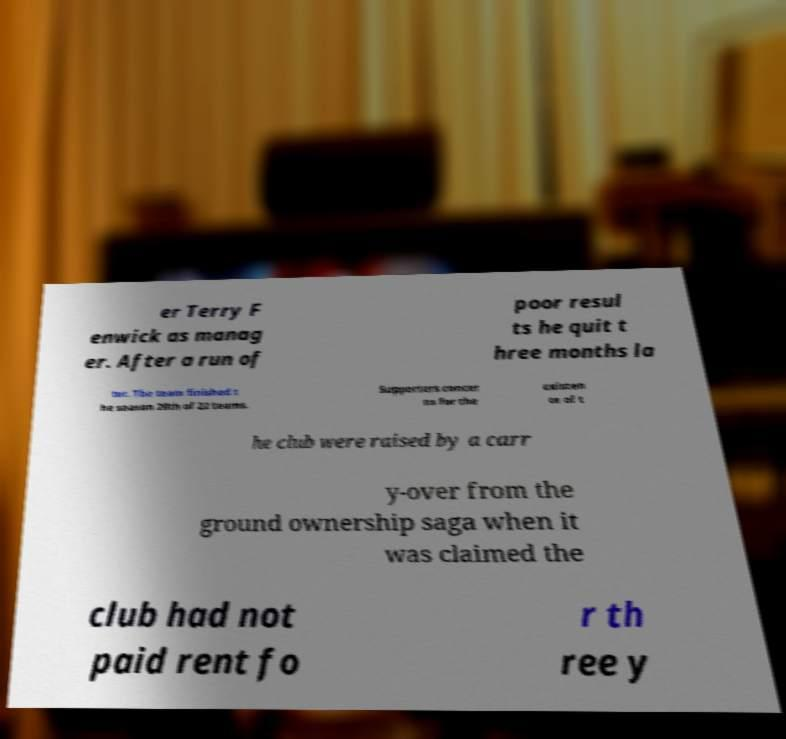There's text embedded in this image that I need extracted. Can you transcribe it verbatim? er Terry F enwick as manag er. After a run of poor resul ts he quit t hree months la ter. The team finished t he season 20th of 22 teams. Supporters concer ns for the existen ce of t he club were raised by a carr y-over from the ground ownership saga when it was claimed the club had not paid rent fo r th ree y 